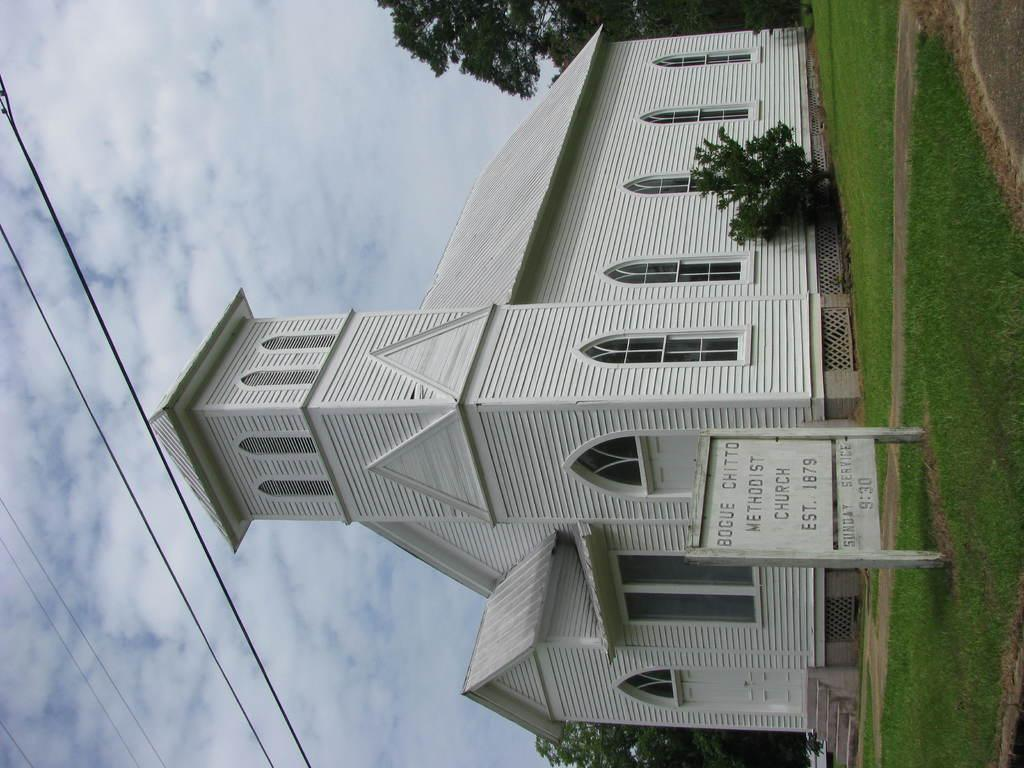<image>
Give a short and clear explanation of the subsequent image. White church, Bogue chitto methodist church est. 1879 